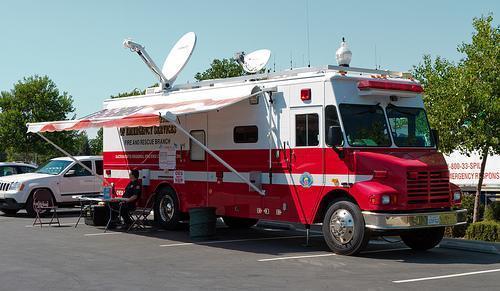How many people are in the image?
Give a very brief answer. 1. 